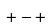<formula> <loc_0><loc_0><loc_500><loc_500>+ - +</formula> 